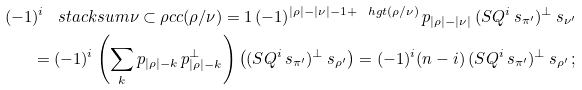<formula> <loc_0><loc_0><loc_500><loc_500>( - 1 ) ^ { i } \, \ s t a c k s u m { \nu \subset \rho } { c c ( \rho / \nu ) = 1 } \, ( - 1 ) ^ { | \rho | - | \nu | - 1 + \ h g t ( \rho / \nu ) } \, p _ { | \rho | - | \nu | } \, ( S Q ^ { i } \, s _ { \pi ^ { \prime } } ) ^ { \perp } \, s _ { \nu ^ { \prime } } \\ = ( - 1 ) ^ { i } \left ( \sum _ { k } p _ { | \rho | - k } \, p _ { | \rho | - k } ^ { \perp } \right ) \left ( ( S Q ^ { i } \, s _ { \pi ^ { \prime } } ) ^ { \perp } \, s _ { \rho ^ { \prime } } \right ) = ( - 1 ) ^ { i } ( n - i ) \, ( S Q ^ { i } \, s _ { \pi ^ { \prime } } ) ^ { \perp } \, s _ { \rho ^ { \prime } } \, ;</formula> 